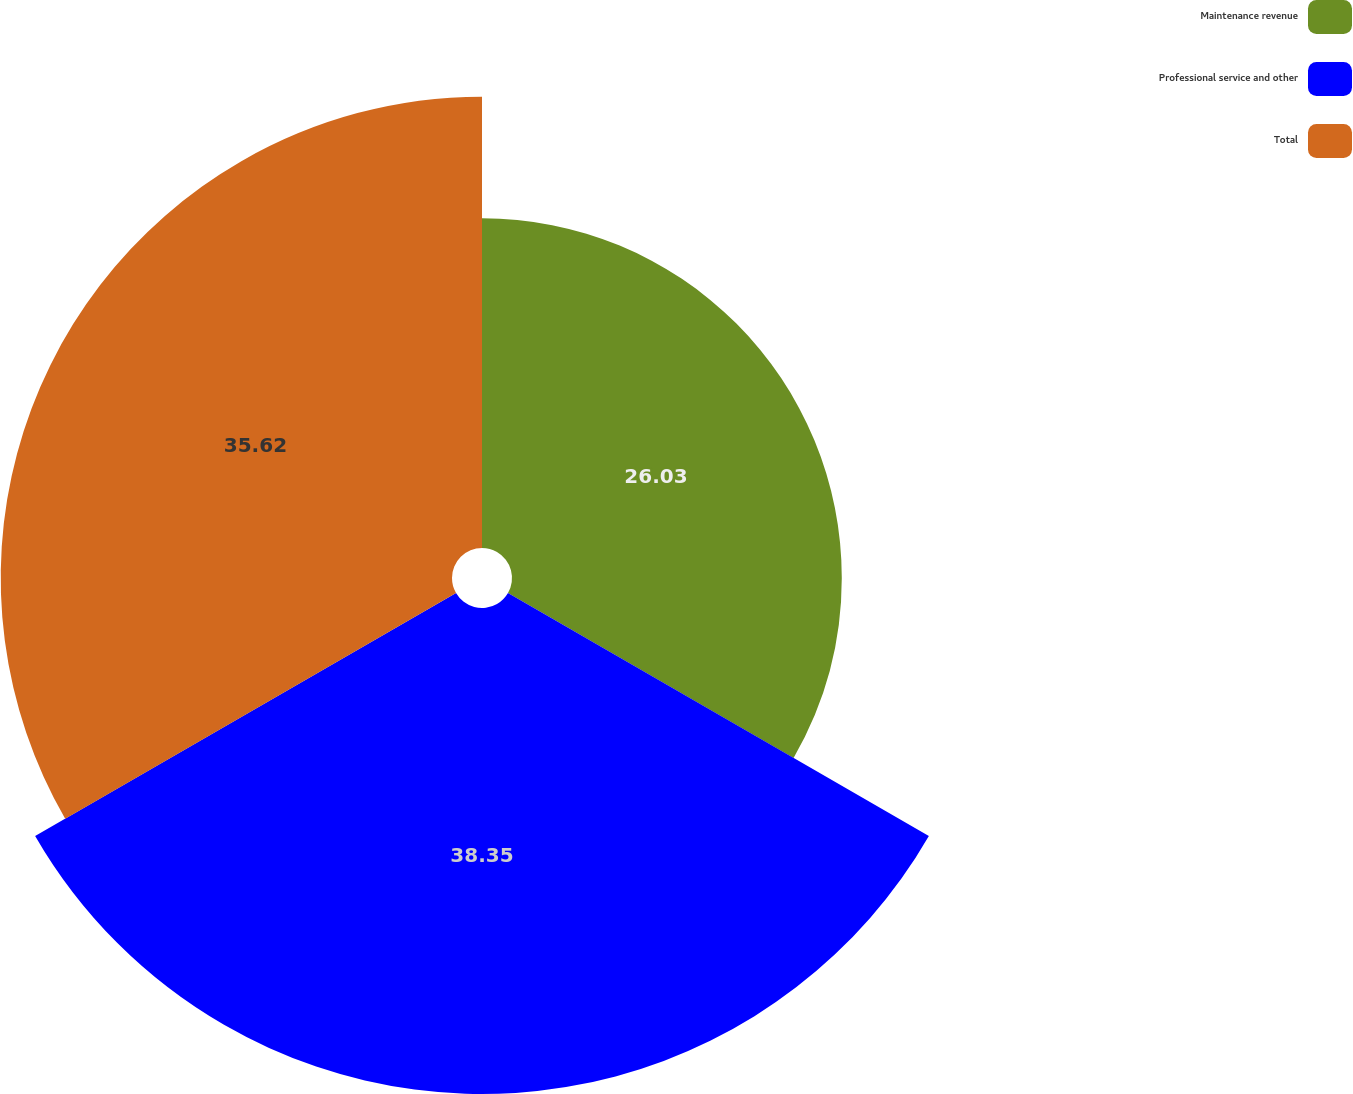Convert chart to OTSL. <chart><loc_0><loc_0><loc_500><loc_500><pie_chart><fcel>Maintenance revenue<fcel>Professional service and other<fcel>Total<nl><fcel>26.03%<fcel>38.36%<fcel>35.62%<nl></chart> 